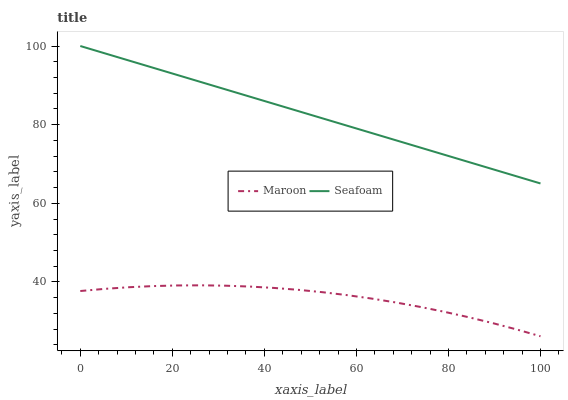Does Maroon have the minimum area under the curve?
Answer yes or no. Yes. Does Seafoam have the maximum area under the curve?
Answer yes or no. Yes. Does Maroon have the maximum area under the curve?
Answer yes or no. No. Is Seafoam the smoothest?
Answer yes or no. Yes. Is Maroon the roughest?
Answer yes or no. Yes. Is Maroon the smoothest?
Answer yes or no. No. Does Maroon have the lowest value?
Answer yes or no. Yes. Does Seafoam have the highest value?
Answer yes or no. Yes. Does Maroon have the highest value?
Answer yes or no. No. Is Maroon less than Seafoam?
Answer yes or no. Yes. Is Seafoam greater than Maroon?
Answer yes or no. Yes. Does Maroon intersect Seafoam?
Answer yes or no. No. 